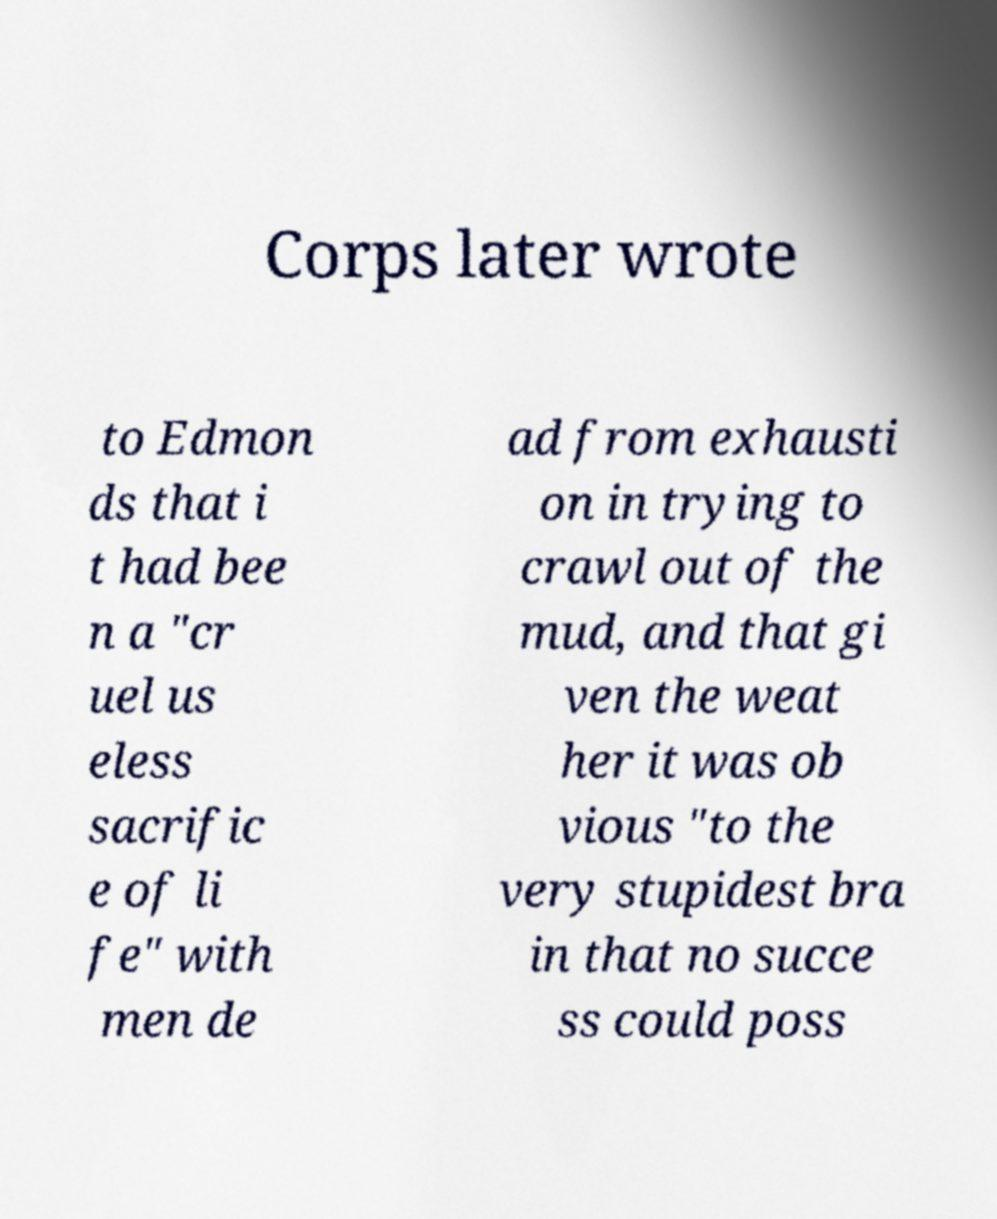Can you read and provide the text displayed in the image?This photo seems to have some interesting text. Can you extract and type it out for me? Corps later wrote to Edmon ds that i t had bee n a "cr uel us eless sacrific e of li fe" with men de ad from exhausti on in trying to crawl out of the mud, and that gi ven the weat her it was ob vious "to the very stupidest bra in that no succe ss could poss 